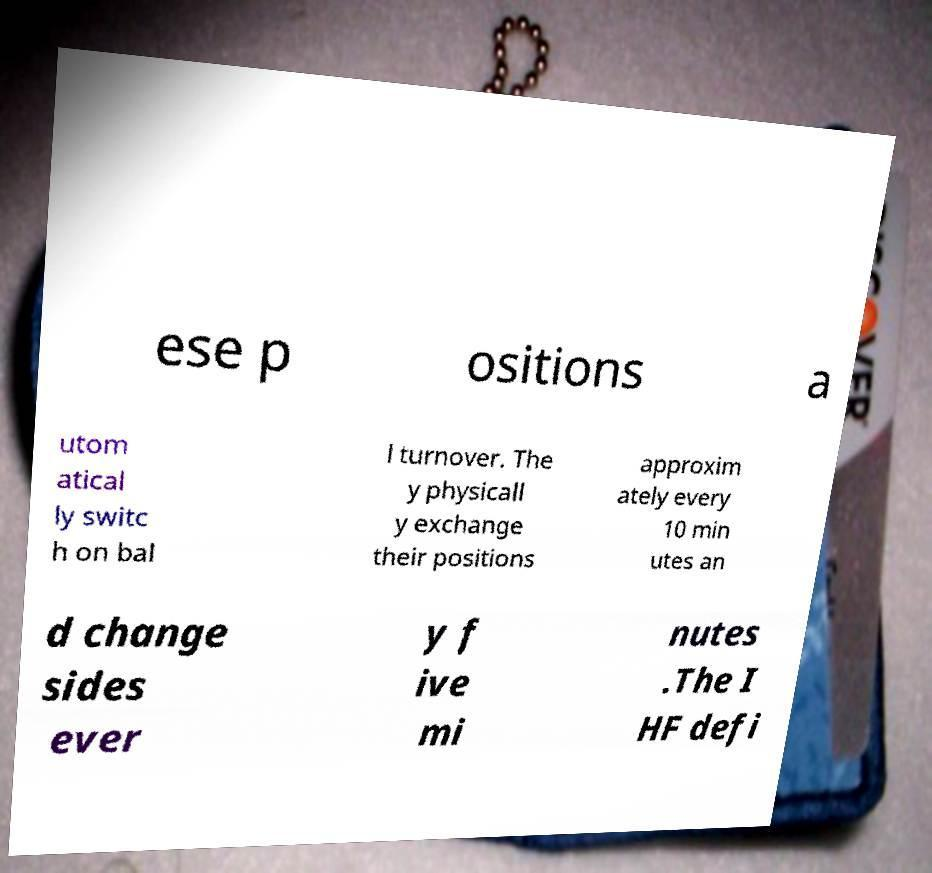There's text embedded in this image that I need extracted. Can you transcribe it verbatim? ese p ositions a utom atical ly switc h on bal l turnover. The y physicall y exchange their positions approxim ately every 10 min utes an d change sides ever y f ive mi nutes .The I HF defi 